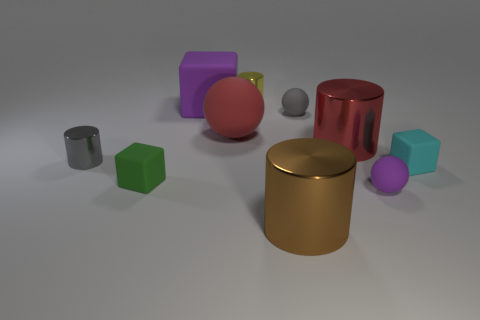There is a large object that is right of the brown metallic thing; what shape is it?
Provide a succinct answer. Cylinder. Is there a brown cylinder to the left of the gray thing that is to the left of the green thing?
Keep it short and to the point. No. What number of things are made of the same material as the gray cylinder?
Provide a short and direct response. 3. How big is the purple rubber thing behind the tiny cube on the left side of the purple rubber sphere in front of the large purple rubber cube?
Your response must be concise. Large. There is a tiny yellow metal object; what number of tiny metal cylinders are on the left side of it?
Offer a very short reply. 1. Is the number of big purple blocks greater than the number of yellow rubber things?
Make the answer very short. Yes. What size is the cylinder that is the same color as the large ball?
Provide a succinct answer. Large. There is a matte cube that is both in front of the red sphere and to the right of the small green cube; what is its size?
Ensure brevity in your answer.  Small. The purple thing behind the green matte thing in front of the tiny metal thing that is in front of the big red cylinder is made of what material?
Your answer should be very brief. Rubber. There is a cylinder that is the same color as the big sphere; what is its material?
Your response must be concise. Metal. 